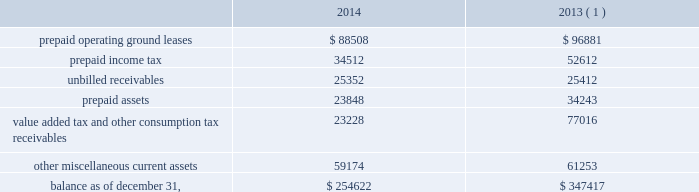American tower corporation and subsidiaries notes to consolidated financial statements of its outstanding restricted stock awards and stock options and uses the if-converted method to calculate the effect of its outstanding mandatory convertible preferred stock .
Retirement plan 2014the company has a 401 ( k ) plan covering substantially all employees who meet certain age and employment requirements .
For the years ended december 31 , 2014 and 2013 , the company matched 75% ( 75 % ) of the first 6% ( 6 % ) of a participant 2019s contributions .
The company 2019s matching contribution for the year ended december 31 , 2012 was 50% ( 50 % ) of the first 6% ( 6 % ) of a participant 2019s contributions .
For the years ended december 31 , 2014 , 2013 and 2012 , the company contributed approximately $ 6.5 million , $ 6.0 million and $ 4.4 million to the plan , respectively .
Accounting standards updates 2014in april 2014 , the financial accounting standards board ( the 201cfasb 201d ) issued additional guidance on reporting discontinued operations .
Under this guidance , only disposals representing a strategic shift in operations would be presented as discontinued operations .
This guidance requires expanded disclosure that provides information about the assets , liabilities , income and expenses of discontinued operations .
Additionally , the guidance requires additional disclosure for a disposal of a significant part of an entity that does not qualify for discontinued operations reporting .
This guidance is effective for reporting periods beginning on or after december 15 , 2014 , with early adoption permitted for disposals or classifications of assets as held-for-sale that have not been reported in financial statements previously issued or available for issuance .
The company chose to early adopt this guidance during the year ended december 31 , 2014 and the adoption did not have a material effect on the company 2019s financial statements .
In may 2014 , the fasb issued new revenue recognition guidance , which requires an entity to recognize revenue in an amount that reflects the consideration to which the entity expects to be entitled in exchange for the transfer of promised goods or services to customers .
The standard will replace most existing revenue recognition guidance in gaap and will become effective on january 1 , 2017 .
The standard permits the use of either the retrospective or cumulative effect transition method , and leases are not included in the scope of this standard .
The company is evaluating the impact this standard may have on its financial statements .
Prepaid and other current assets prepaid and other current assets consists of the following as of december 31 , ( in thousands ) : .
( 1 ) december 31 , 2013 balances have been revised to reflect purchase accounting measurement period adjustments. .
Assuming maximum participant contributions , what was the change in company match percentage between 2014 and 2013? 
Computations: ((75% * 6%) - (50% * 6%))
Answer: 0.015. 